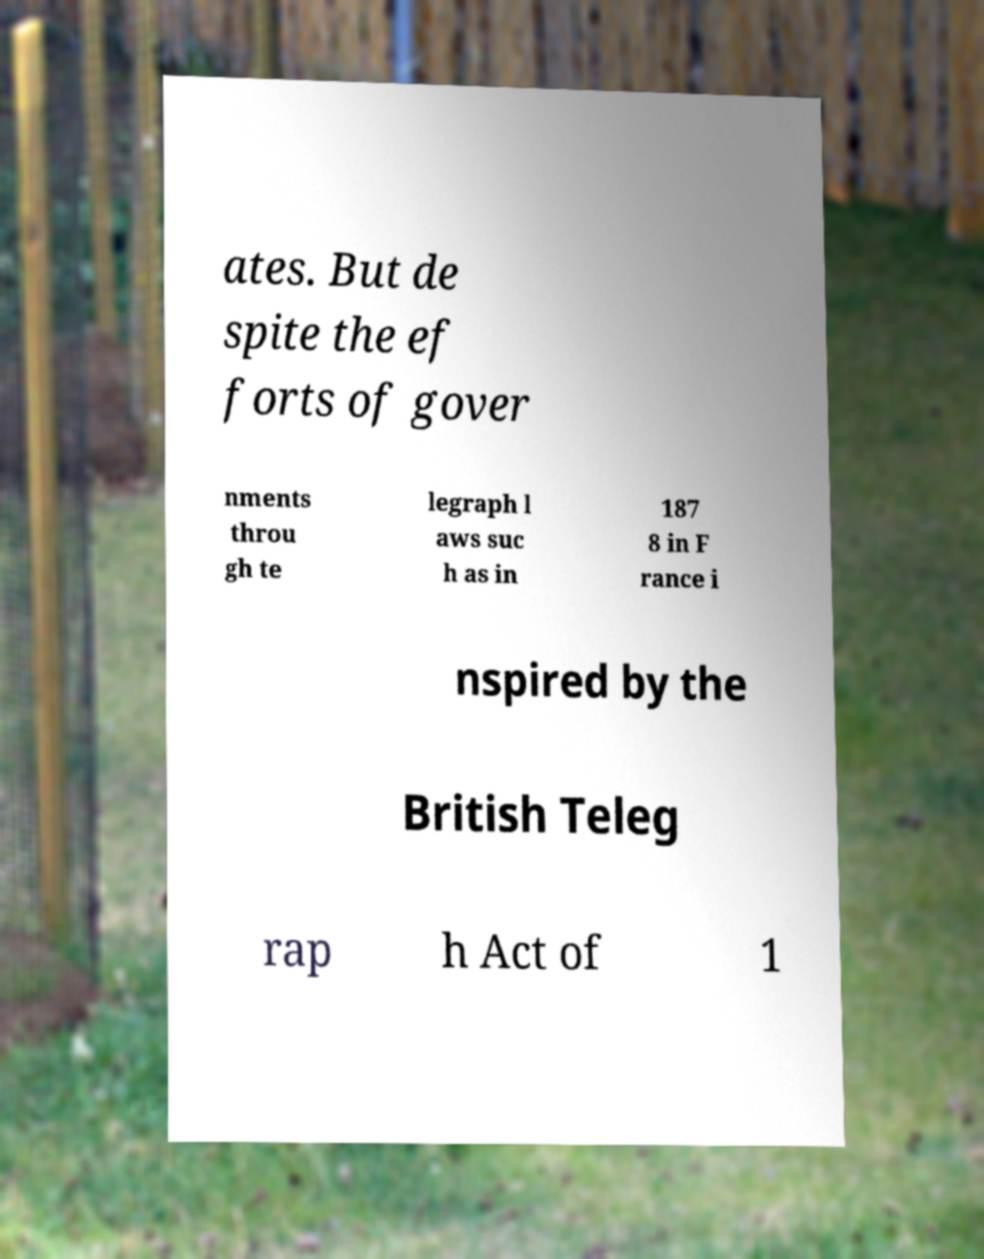I need the written content from this picture converted into text. Can you do that? ates. But de spite the ef forts of gover nments throu gh te legraph l aws suc h as in 187 8 in F rance i nspired by the British Teleg rap h Act of 1 